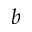<formula> <loc_0><loc_0><loc_500><loc_500>^ { b }</formula> 